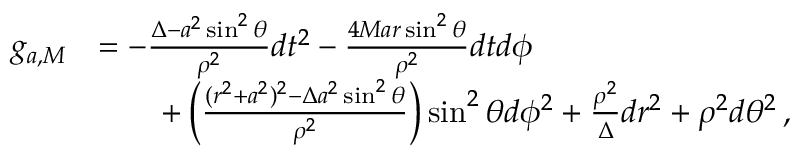<formula> <loc_0><loc_0><loc_500><loc_500>\begin{array} { r l } { g _ { a , M } } & { = - \frac { \Delta - a ^ { 2 } \sin ^ { 2 } \theta } { \rho ^ { 2 } } d t ^ { 2 } - \frac { 4 M a r \sin ^ { 2 } \theta } { \rho ^ { 2 } } d t d \phi } \\ & { \quad + \left ( \frac { ( r ^ { 2 } + a ^ { 2 } ) ^ { 2 } - \Delta a ^ { 2 } \sin ^ { 2 } \theta } { \rho ^ { 2 } } \right ) \sin ^ { 2 } \theta d \phi ^ { 2 } + \frac { \rho ^ { 2 } } { \Delta } d r ^ { 2 } + \rho ^ { 2 } d \theta ^ { 2 } \, , } \end{array}</formula> 